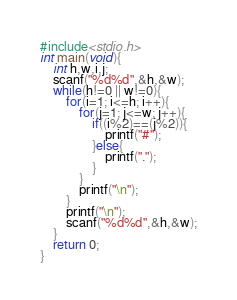<code> <loc_0><loc_0><loc_500><loc_500><_C_>#include<stdio.h>
int main(void){
    int h,w,i,j;
    scanf("%d%d",&h,&w);
    while(h!=0 || w!=0){
        for(i=1; i<=h; i++){
            for(j=1; j<=w; j++){
                if((i%2)==(j%2)){
                    printf("#");
                }else{
                    printf(".");
                }
            }
            printf("\n");
        }
        printf("\n");
        scanf("%d%d",&h,&w);
    }
    return 0;
}</code> 